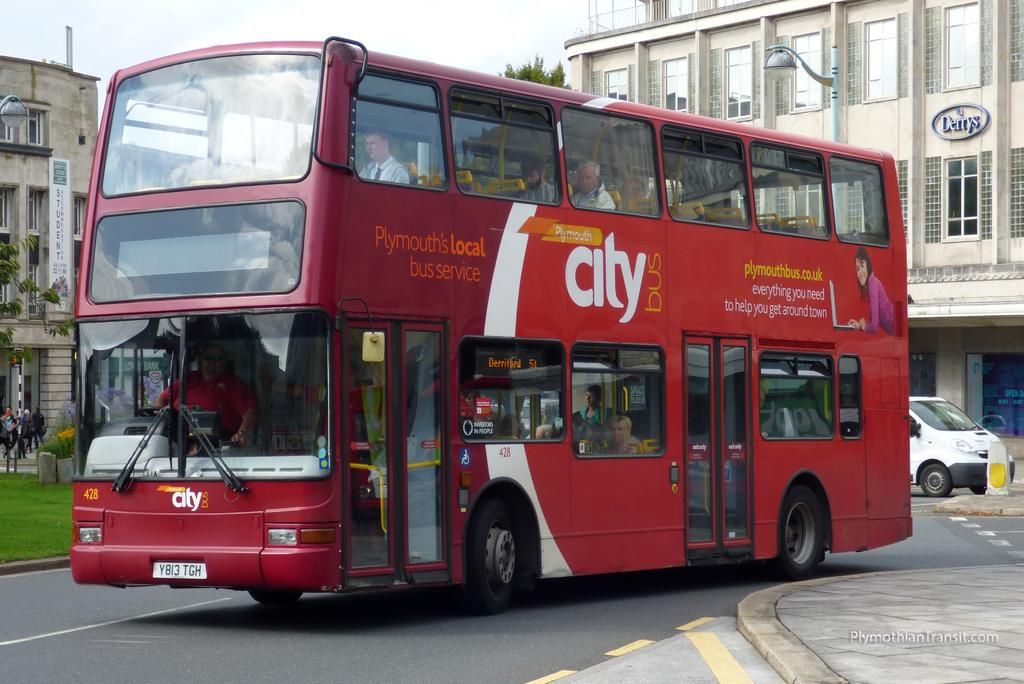<image>
Render a clear and concise summary of the photo. a double decker Plymouth's Local city bus service bus saying everything you need to get around town. 